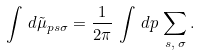Convert formula to latex. <formula><loc_0><loc_0><loc_500><loc_500>\int \, d \tilde { \mu } _ { p s \sigma } = \frac { 1 } { 2 \pi } \, \int \, d p \, \sum _ { s , \, \sigma } .</formula> 